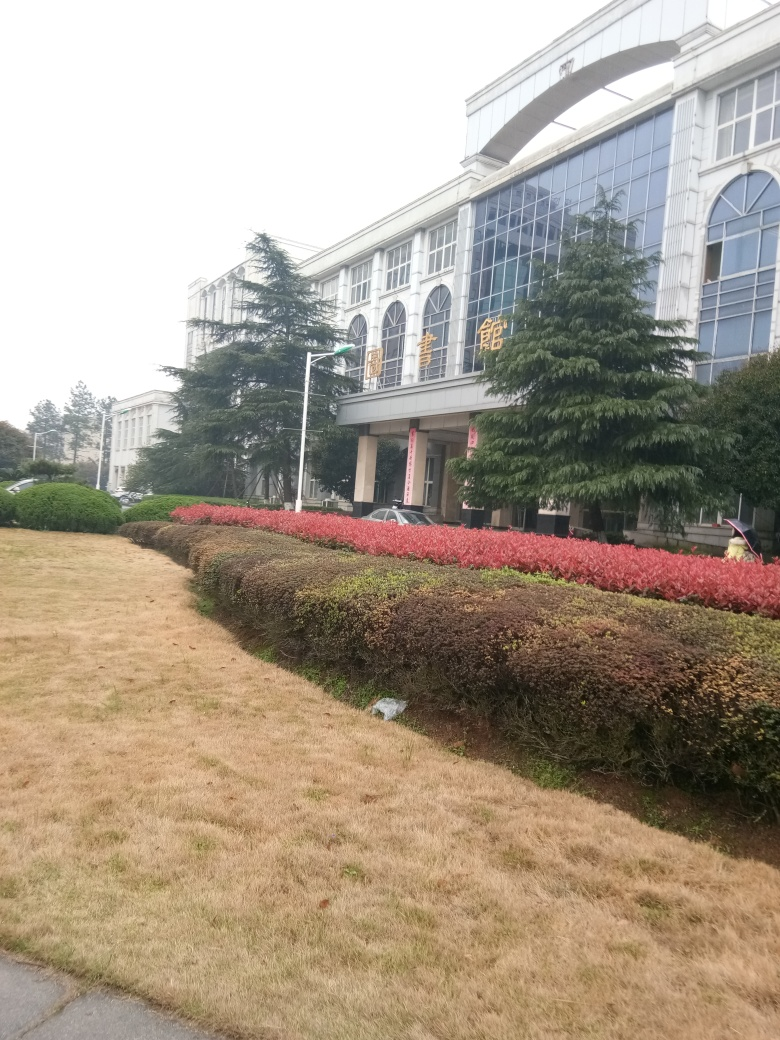Is this environment conducive to relaxation or studying? Given the image portrays what seems to be a formal and possibly educational setting with peaceful landscaping, it likely provides a conducive atmosphere for studying. However, for relaxation, it may depend on personal preference, as some people might find the structured and manicured environment less inviting for leisure. 